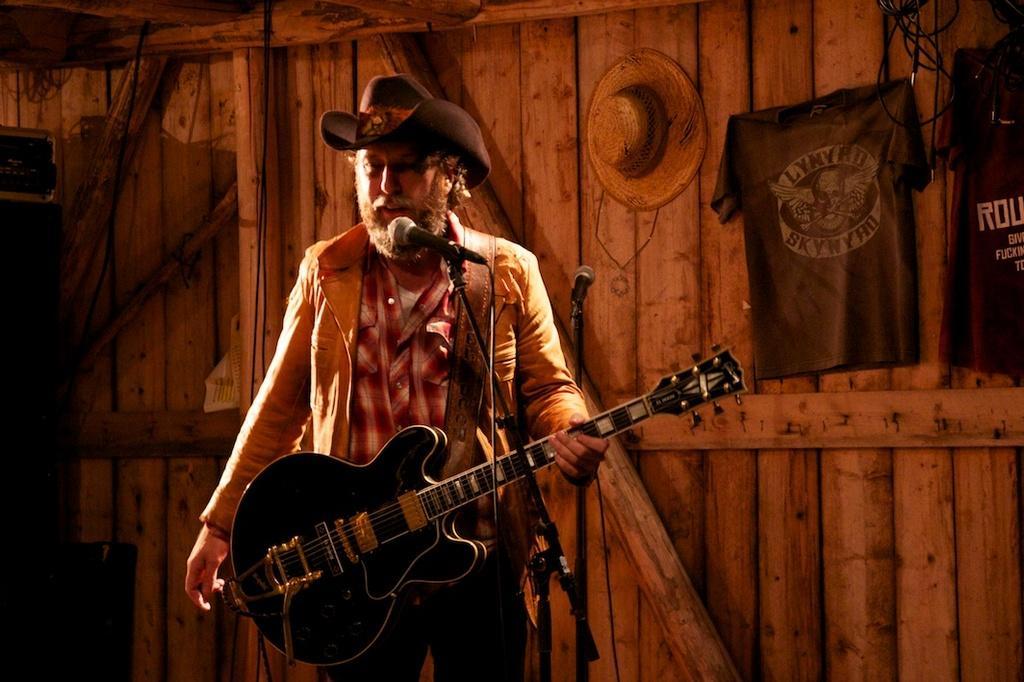How would you summarize this image in a sentence or two? There is a man with brown jacket and red shirt is standing and playing guitar. In front of him there is a mic. To the right corner there are two shirts and one hat to the wooden wall. 